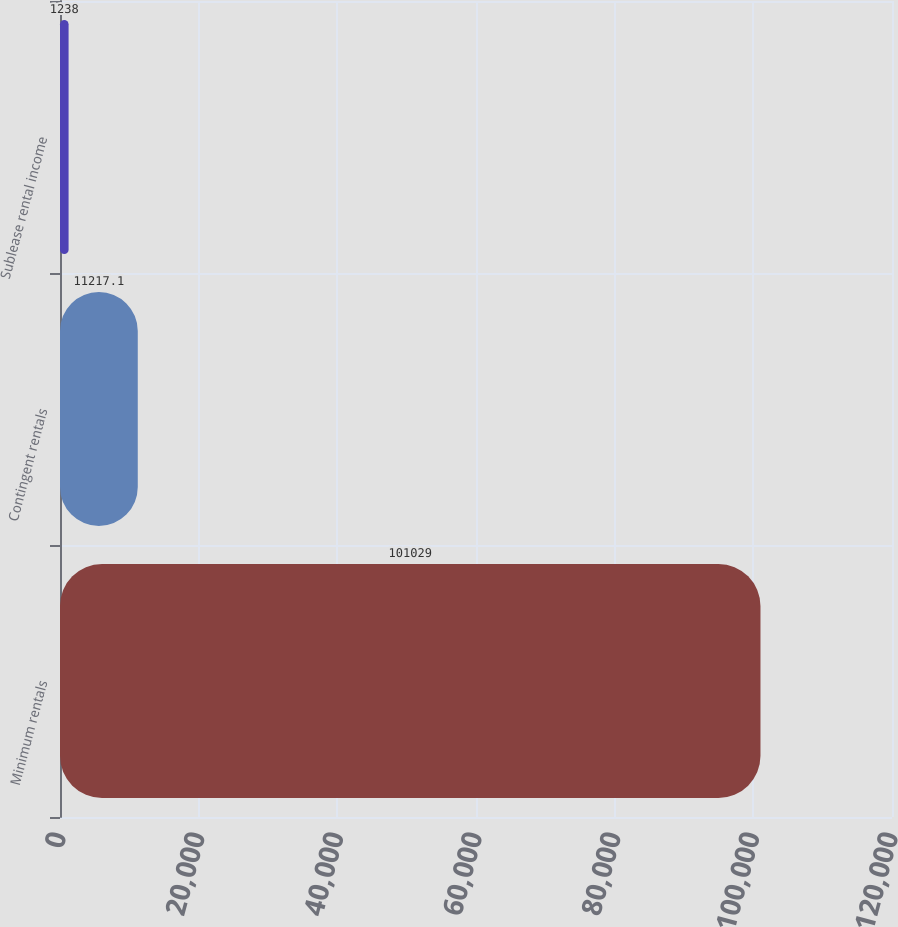<chart> <loc_0><loc_0><loc_500><loc_500><bar_chart><fcel>Minimum rentals<fcel>Contingent rentals<fcel>Sublease rental income<nl><fcel>101029<fcel>11217.1<fcel>1238<nl></chart> 